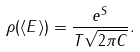<formula> <loc_0><loc_0><loc_500><loc_500>\rho ( \langle E \rangle ) = \frac { e ^ { S } } { T \sqrt { 2 \pi C } } .</formula> 